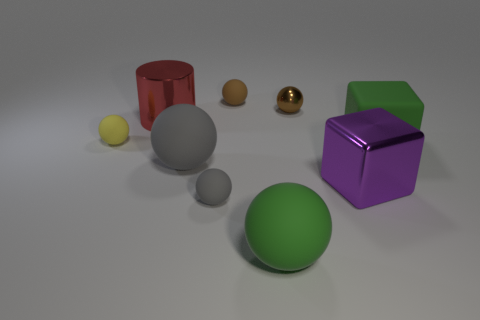How many balls have the same color as the matte block?
Provide a succinct answer. 1. Are there fewer tiny balls in front of the big green ball than large green spheres that are behind the tiny metal ball?
Provide a succinct answer. No. There is a large green object that is in front of the small gray rubber object; does it have the same shape as the brown matte object?
Your response must be concise. Yes. Are there any other things that are the same material as the yellow thing?
Offer a very short reply. Yes. Is the material of the large green object to the left of the green matte cube the same as the cylinder?
Make the answer very short. No. There is a large thing to the left of the gray object on the left side of the tiny matte sphere in front of the big purple metal cube; what is its material?
Keep it short and to the point. Metal. What number of other things are the same shape as the large gray object?
Offer a very short reply. 5. What is the color of the big metal thing in front of the yellow matte sphere?
Offer a terse response. Purple. How many brown balls are on the left side of the tiny matte thing that is behind the rubber thing left of the big gray matte ball?
Ensure brevity in your answer.  0. What number of small gray matte balls are to the right of the small brown object right of the large green rubber sphere?
Your answer should be very brief. 0. 